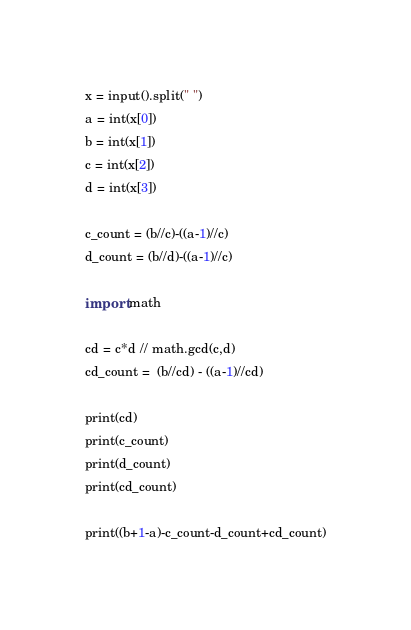Convert code to text. <code><loc_0><loc_0><loc_500><loc_500><_Python_>x = input().split(" ")
a = int(x[0])
b = int(x[1])
c = int(x[2])
d = int(x[3])

c_count = (b//c)-((a-1)//c)
d_count = (b//d)-((a-1)//c)

import math

cd = c*d // math.gcd(c,d)
cd_count =  (b//cd) - ((a-1)//cd)

print(cd)
print(c_count)
print(d_count)
print(cd_count)

print((b+1-a)-c_count-d_count+cd_count)</code> 